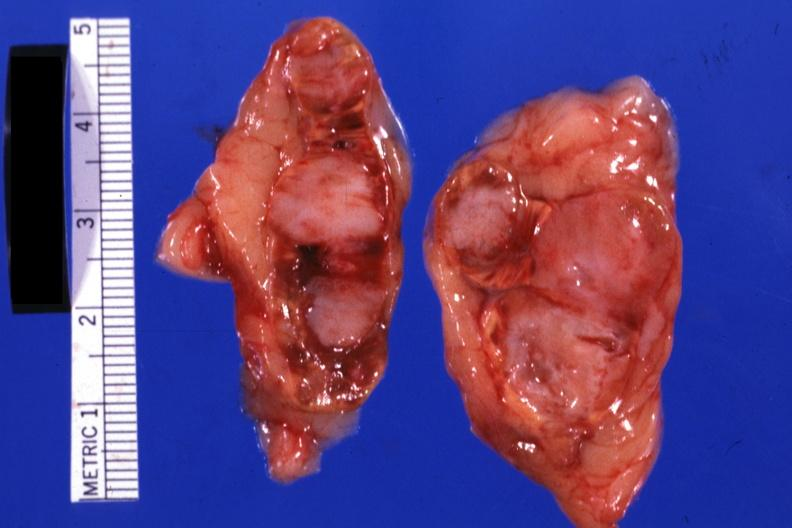what does this image show?
Answer the question using a single word or phrase. Extensive lesions scar carcinoma in lung 